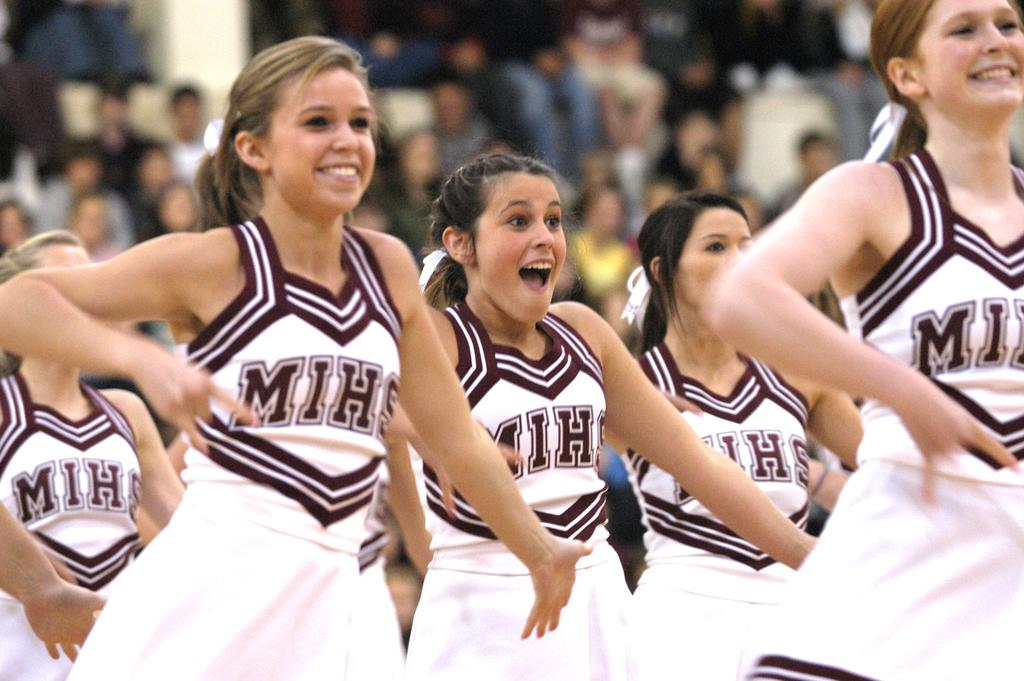<image>
Offer a succinct explanation of the picture presented. A group of cheerleaders with the girls wearing MIHS uniforms 